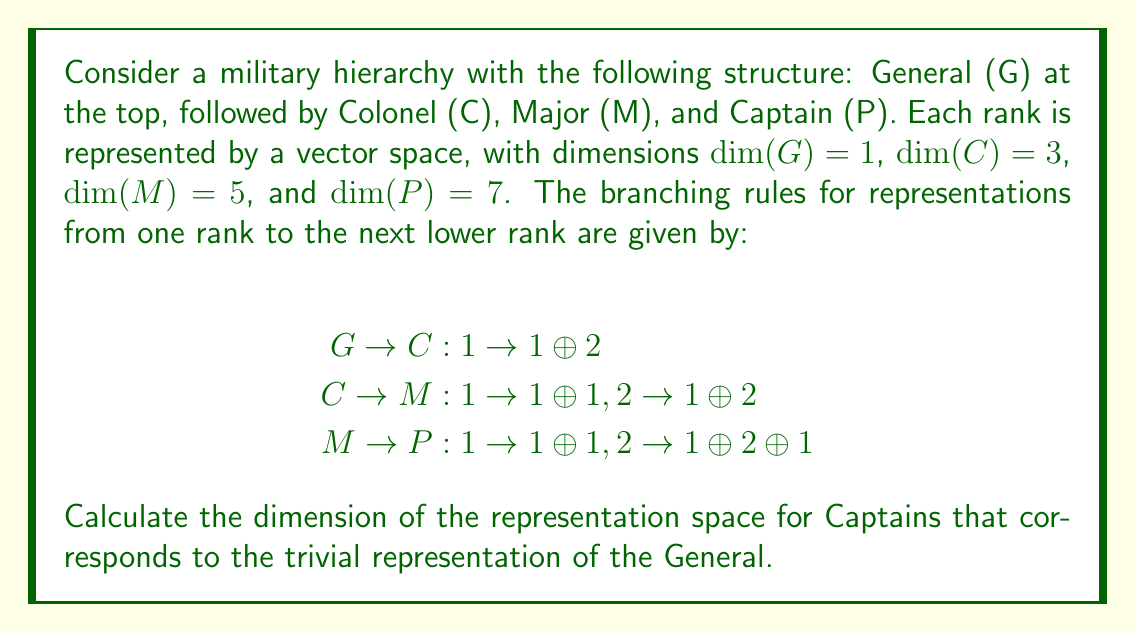Can you answer this question? To solve this problem, we need to follow the branching rules from the General (G) down to the Captain (P) level. We'll track how the trivial representation of G (dimension 1) branches at each step.

Step 1: G → C
The trivial representation of G (dimension 1) branches to 1 ⊕ 2 in C.
$\dim = 1 + 2 = 3$

Step 2: C → M
1 → 1 ⊕ 1
2 → 1 ⊕ 2
So, (1 ⊕ 2) → (1 ⊕ 1) ⊕ (1 ⊕ 2) = 1 ⊕ 1 ⊕ 1 ⊕ 2
$\dim = 1 + 1 + 1 + 2 = 5$

Step 3: M → P
1 → 1 ⊕ 1
2 → 1 ⊕ 2 ⊕ 1
So, (1 ⊕ 1 ⊕ 1 ⊕ 2) → (1 ⊕ 1) ⊕ (1 ⊕ 1) ⊕ (1 ⊕ 1) ⊕ (1 ⊕ 2 ⊕ 1)
$\dim = (1 + 1) + (1 + 1) + (1 + 1) + (1 + 2 + 1) = 2 + 2 + 2 + 4 = 10$

Therefore, the dimension of the representation space for Captains that corresponds to the trivial representation of the General is 10.
Answer: 10 